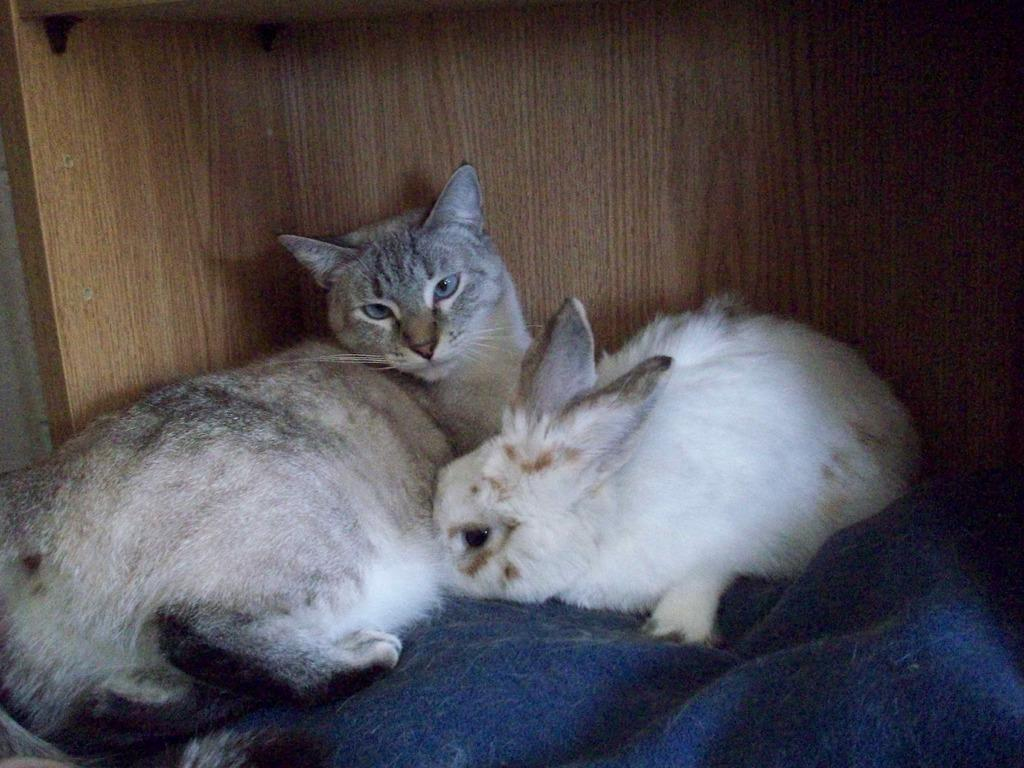What animals are present in the image? There is a cat and a rabbit in the image. What are the cat and rabbit doing in the image? The cat and rabbit are sitting in something. What grade is the cat in the image? There is no indication of a grade or educational context in the image, as it features a cat and a rabbit sitting together. 